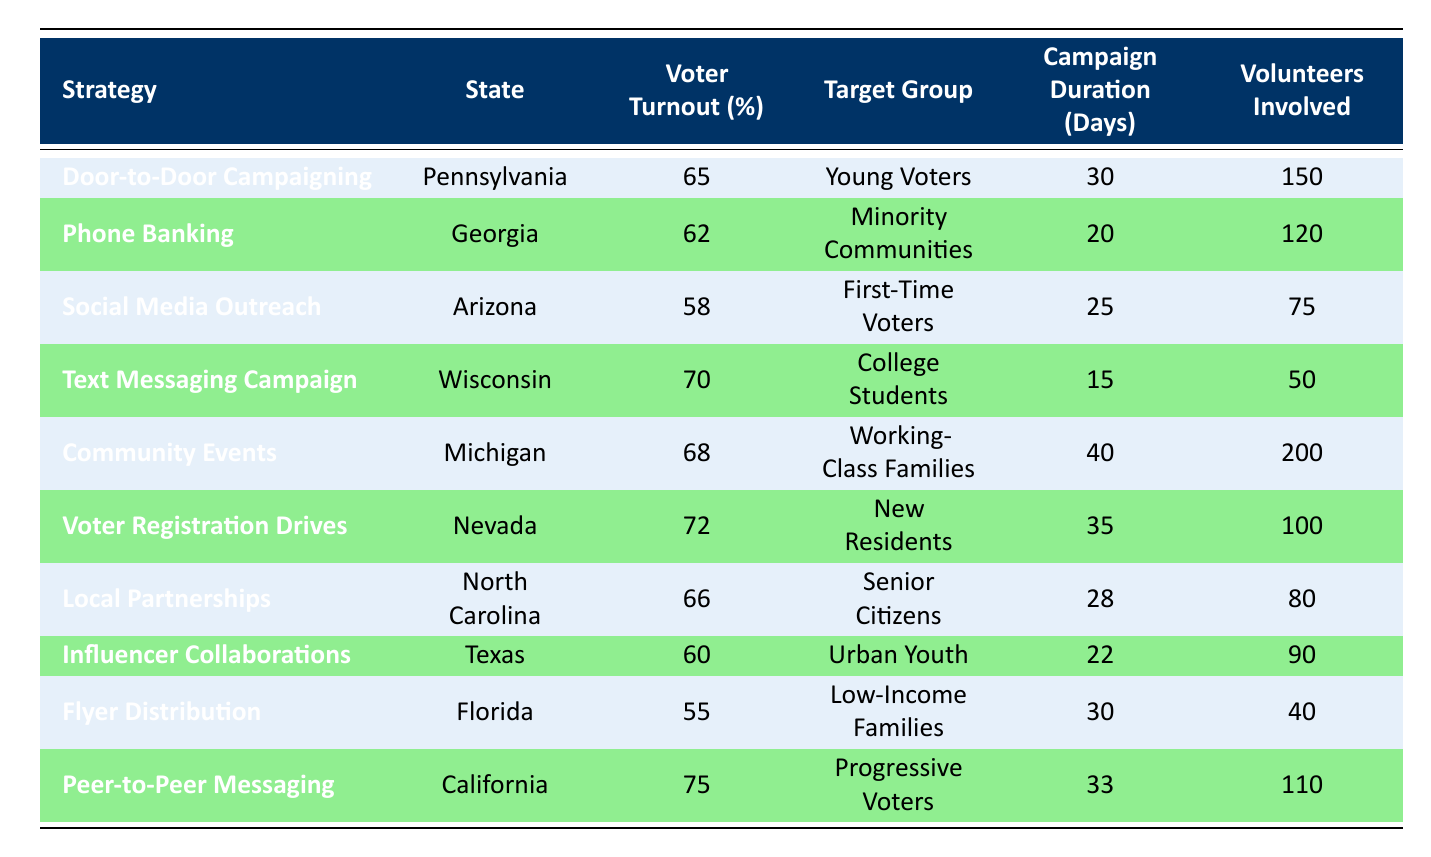What is the voter turnout percentage for the Voter Registration Drives strategy in Nevada? The table indicates that under the "Voter Registration Drives" strategy in Nevada, the voter turnout percentage is explicitly listed as 72%.
Answer: 72% What strategy had the highest voter turnout percentage? By examining the "Voter Turnout (%)" column, "Peer-to-Peer Messaging" in California has the highest percentage at 75%.
Answer: 75% Is the voter turnout from the Phone Banking strategy greater than 60%? The table shows that the voter turnout percentage for the Phone Banking strategy in Georgia is 62%, which is greater than 60%.
Answer: Yes How many volunteers were involved in the Community Events strategy in Michigan? Referring to the table, the number of volunteers involved in the "Community Events" strategy in Michigan is 200.
Answer: 200 What is the average voter turnout for strategies targeting Young Voters and College Students? The voter turnout percentages for these groups are 65% (Young Voters) and 70% (College Students). Adding these gives 135%. Dividing by 2 gives an average of 67.5%.
Answer: 67.5% Which state used the strategy of Door-to-Door Campaigning? According to the table, the state that implemented the "Door-to-Door Campaigning" strategy is Pennsylvania.
Answer: Pennsylvania Was the Campaign Duration for the Social Media Outreach strategy longer than 20 days? The table indicates that the Campaign Duration for Social Media Outreach in Arizona is 25 days, which is indeed longer than 20 days.
Answer: Yes What is the difference in voter turnout between the Flyer Distribution and Text Messaging Campaign strategies? The voter turnout for Flyer Distribution is 55%, and for Text Messaging Campaign, it is 70%. The difference is calculated as 70% - 55% = 15%.
Answer: 15% Do the strategies with the highest voter turnout percentages also have the highest number of volunteers involved? The strategy with the highest voter turnout is "Peer-to-Peer Messaging" with 75% and 110 volunteers, while "Community Events" also has a high turnout of 68% but with 200 volunteers. Thus, high turnout doesn’t directly correlate with high volunteer numbers.
Answer: No 